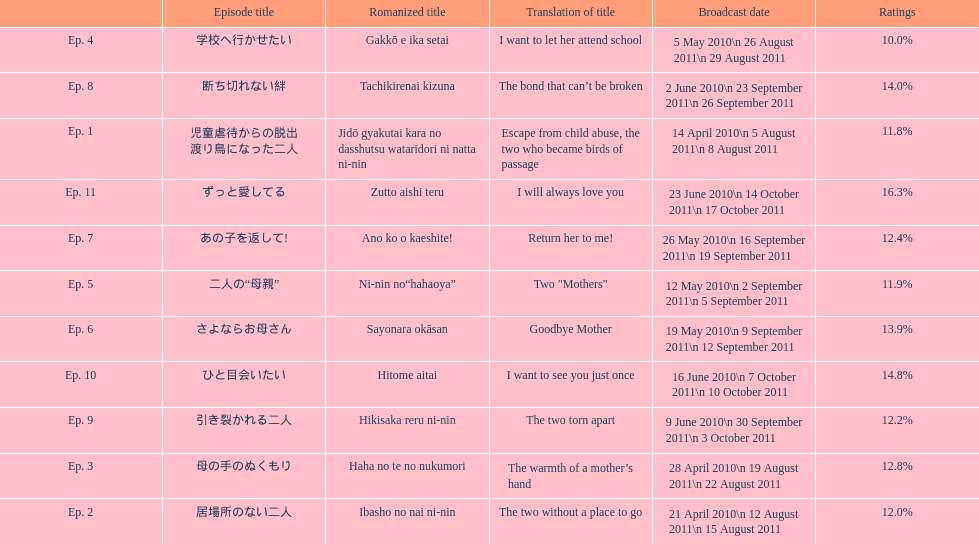How many episode total are there? 11. 